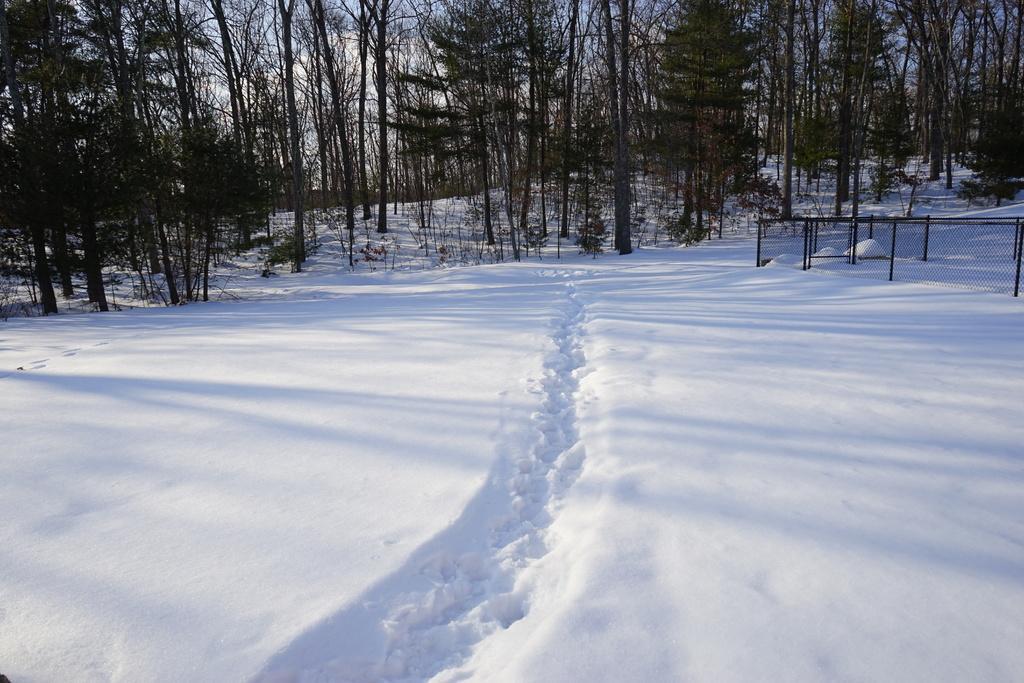Please provide a concise description of this image. In this image, we can see some snow. There are trees at the top of the image. There is a fence on the right side of the image. 